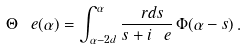Convert formula to latex. <formula><loc_0><loc_0><loc_500><loc_500>\Theta _ { \ } e ( \alpha ) = \int ^ { \alpha } _ { \alpha - 2 d } \frac { \ r d s } { s + i \ e } \, \Phi ( \alpha - s ) \, .</formula> 